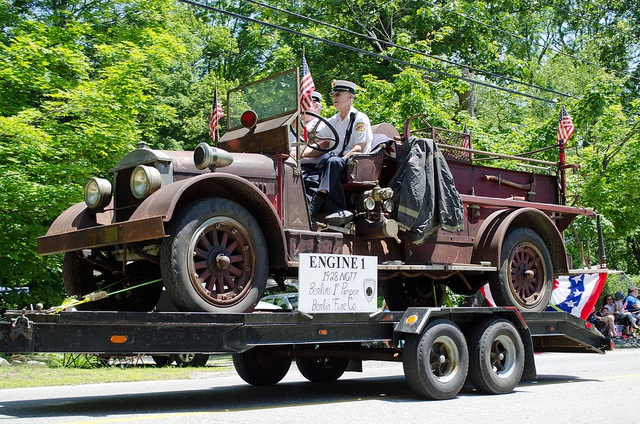Describe the objects in this image and their specific colors. I can see truck in green, black, gray, darkgray, and maroon tones, truck in green, black, gray, lightgray, and darkgray tones, people in green, black, darkgray, and lightgray tones, people in green, lightgray, lightpink, darkgray, and maroon tones, and people in green, black, and gray tones in this image. 